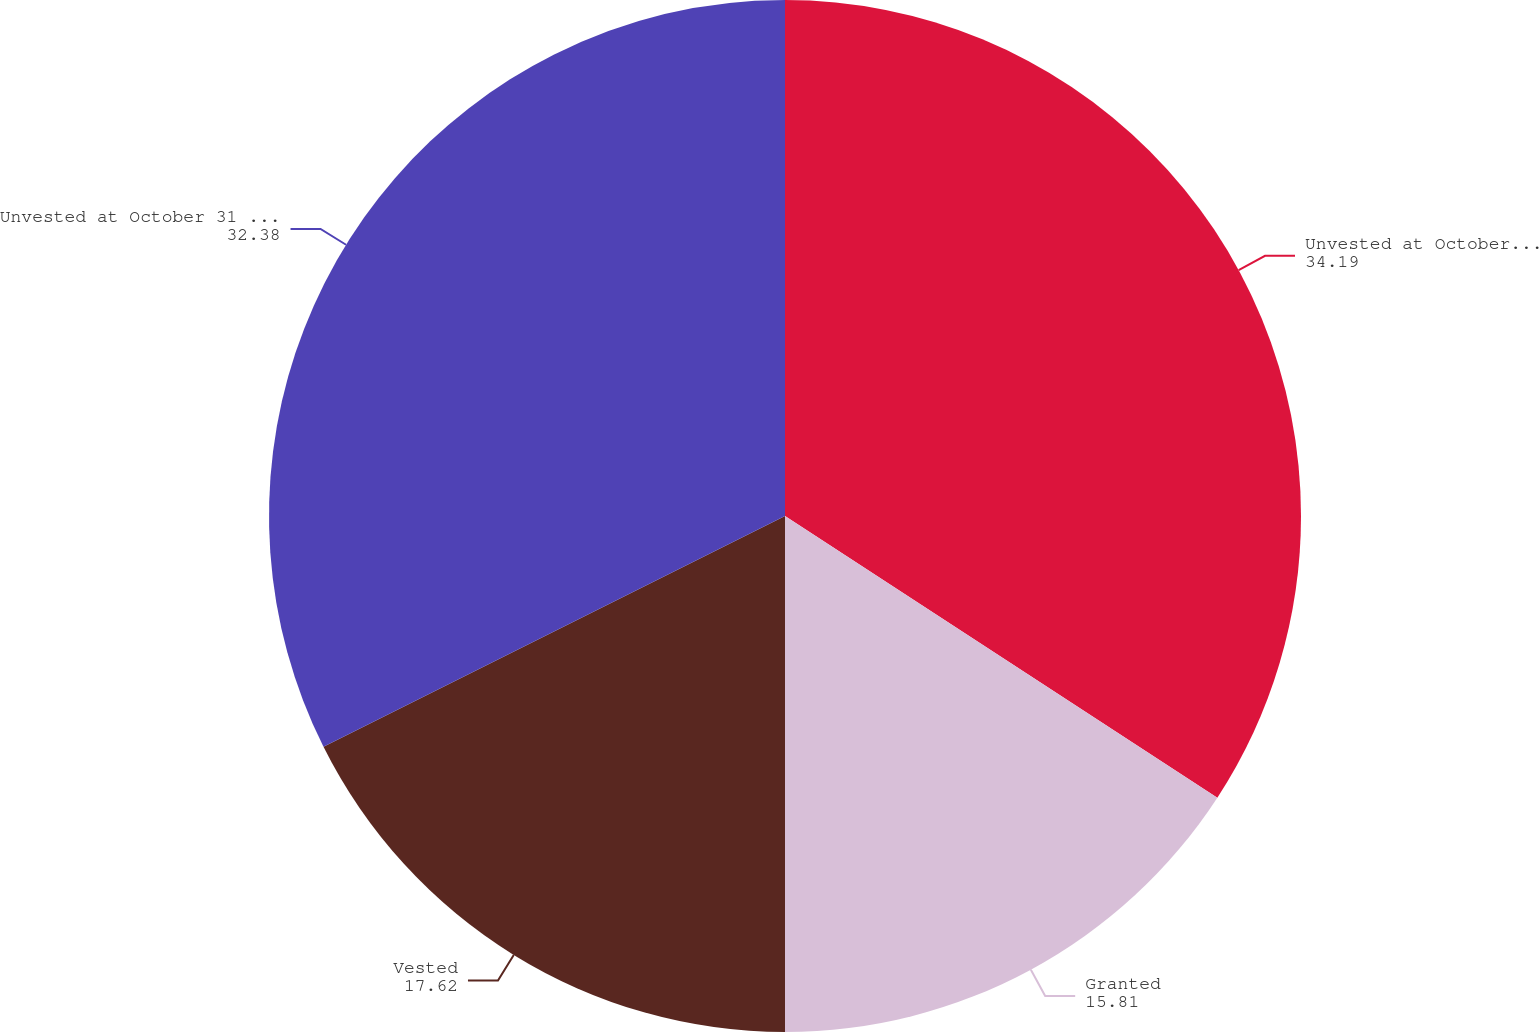Convert chart to OTSL. <chart><loc_0><loc_0><loc_500><loc_500><pie_chart><fcel>Unvested at October 31 2015<fcel>Granted<fcel>Vested<fcel>Unvested at October 31 2016<nl><fcel>34.19%<fcel>15.81%<fcel>17.62%<fcel>32.38%<nl></chart> 